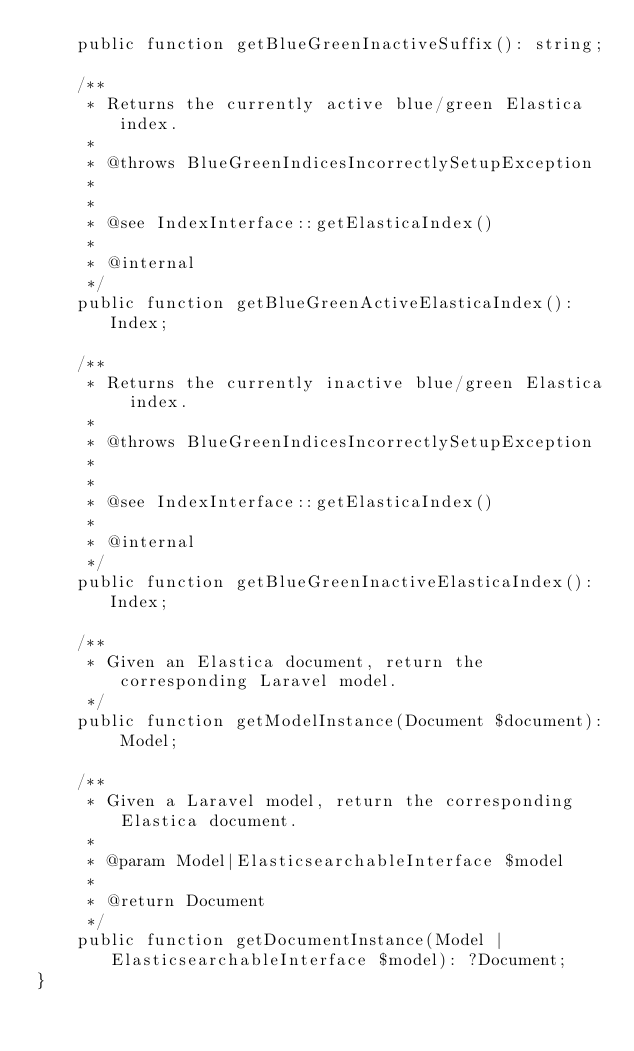<code> <loc_0><loc_0><loc_500><loc_500><_PHP_>    public function getBlueGreenInactiveSuffix(): string;

    /**
     * Returns the currently active blue/green Elastica index.
     *
     * @throws BlueGreenIndicesIncorrectlySetupException
     *
     *
     * @see IndexInterface::getElasticaIndex()
     *
     * @internal
     */
    public function getBlueGreenActiveElasticaIndex(): Index;

    /**
     * Returns the currently inactive blue/green Elastica index.
     *
     * @throws BlueGreenIndicesIncorrectlySetupException
     *
     *
     * @see IndexInterface::getElasticaIndex()
     *
     * @internal
     */
    public function getBlueGreenInactiveElasticaIndex(): Index;

    /**
     * Given an Elastica document, return the corresponding Laravel model.
     */
    public function getModelInstance(Document $document): Model;

    /**
     * Given a Laravel model, return the corresponding Elastica document.
     *
     * @param Model|ElasticsearchableInterface $model
     *
     * @return Document
     */
    public function getDocumentInstance(Model | ElasticsearchableInterface $model): ?Document;
}
</code> 